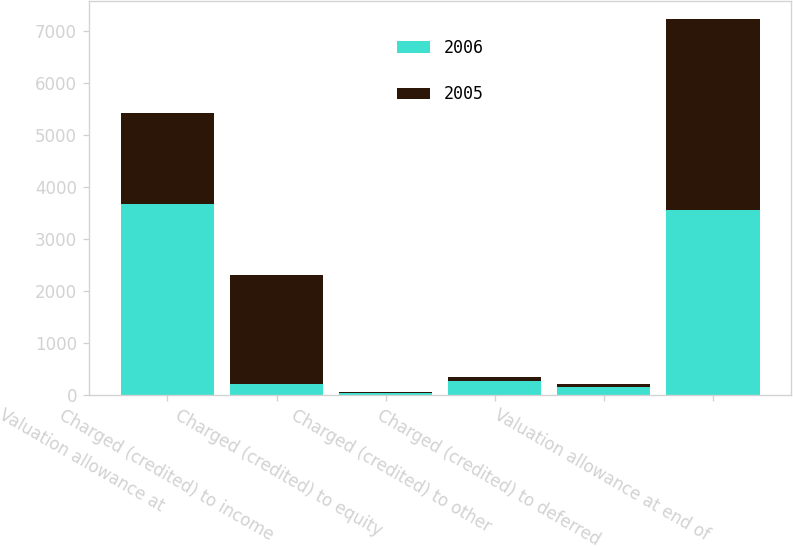Convert chart. <chart><loc_0><loc_0><loc_500><loc_500><stacked_bar_chart><ecel><fcel>Valuation allowance at<fcel>Charged (credited) to income<fcel>Charged (credited) to equity<fcel>Charged (credited) to other<fcel>Charged (credited) to deferred<fcel>Valuation allowance at end of<nl><fcel>2006<fcel>3672<fcel>211<fcel>28<fcel>258<fcel>149<fcel>3542<nl><fcel>2005<fcel>1747<fcel>2089<fcel>22<fcel>91<fcel>51<fcel>3672<nl></chart> 